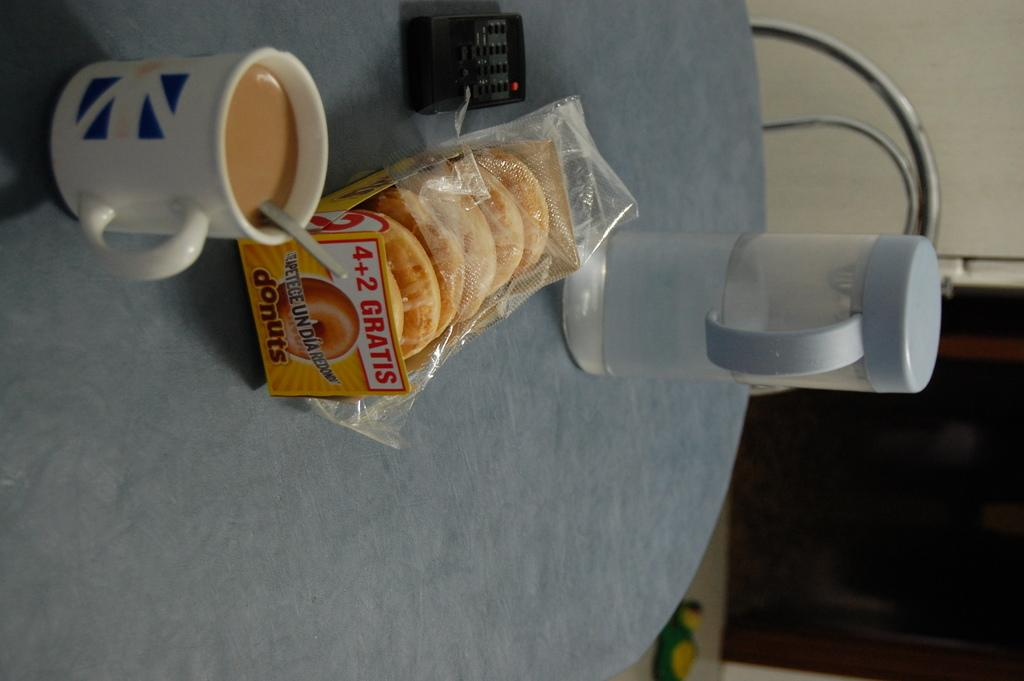Provide a one-sentence caption for the provided image. back of crackers and a coffee placed on the table. 